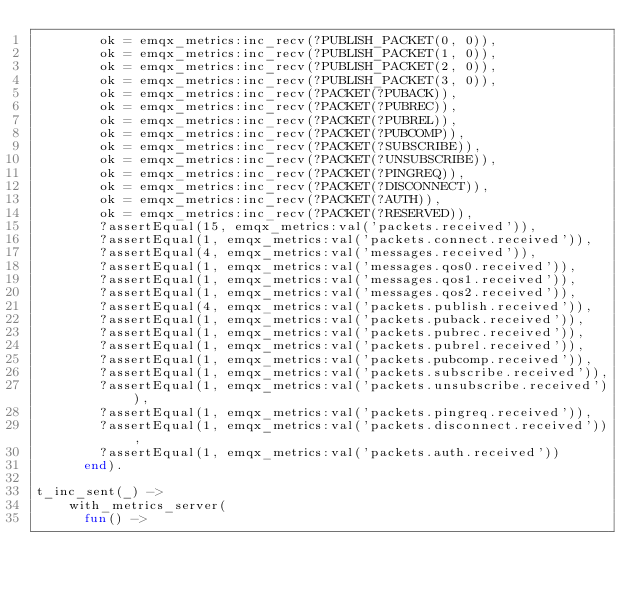<code> <loc_0><loc_0><loc_500><loc_500><_Erlang_>        ok = emqx_metrics:inc_recv(?PUBLISH_PACKET(0, 0)),
        ok = emqx_metrics:inc_recv(?PUBLISH_PACKET(1, 0)),
        ok = emqx_metrics:inc_recv(?PUBLISH_PACKET(2, 0)),
        ok = emqx_metrics:inc_recv(?PUBLISH_PACKET(3, 0)),
        ok = emqx_metrics:inc_recv(?PACKET(?PUBACK)),
        ok = emqx_metrics:inc_recv(?PACKET(?PUBREC)),
        ok = emqx_metrics:inc_recv(?PACKET(?PUBREL)),
        ok = emqx_metrics:inc_recv(?PACKET(?PUBCOMP)),
        ok = emqx_metrics:inc_recv(?PACKET(?SUBSCRIBE)),
        ok = emqx_metrics:inc_recv(?PACKET(?UNSUBSCRIBE)),
        ok = emqx_metrics:inc_recv(?PACKET(?PINGREQ)),
        ok = emqx_metrics:inc_recv(?PACKET(?DISCONNECT)),
        ok = emqx_metrics:inc_recv(?PACKET(?AUTH)),
        ok = emqx_metrics:inc_recv(?PACKET(?RESERVED)),
        ?assertEqual(15, emqx_metrics:val('packets.received')),
        ?assertEqual(1, emqx_metrics:val('packets.connect.received')),
        ?assertEqual(4, emqx_metrics:val('messages.received')),
        ?assertEqual(1, emqx_metrics:val('messages.qos0.received')),
        ?assertEqual(1, emqx_metrics:val('messages.qos1.received')),
        ?assertEqual(1, emqx_metrics:val('messages.qos2.received')),
        ?assertEqual(4, emqx_metrics:val('packets.publish.received')),
        ?assertEqual(1, emqx_metrics:val('packets.puback.received')),
        ?assertEqual(1, emqx_metrics:val('packets.pubrec.received')),
        ?assertEqual(1, emqx_metrics:val('packets.pubrel.received')),
        ?assertEqual(1, emqx_metrics:val('packets.pubcomp.received')),
        ?assertEqual(1, emqx_metrics:val('packets.subscribe.received')),
        ?assertEqual(1, emqx_metrics:val('packets.unsubscribe.received')),
        ?assertEqual(1, emqx_metrics:val('packets.pingreq.received')),
        ?assertEqual(1, emqx_metrics:val('packets.disconnect.received')),
        ?assertEqual(1, emqx_metrics:val('packets.auth.received'))
      end).

t_inc_sent(_) ->
    with_metrics_server(
      fun() -></code> 